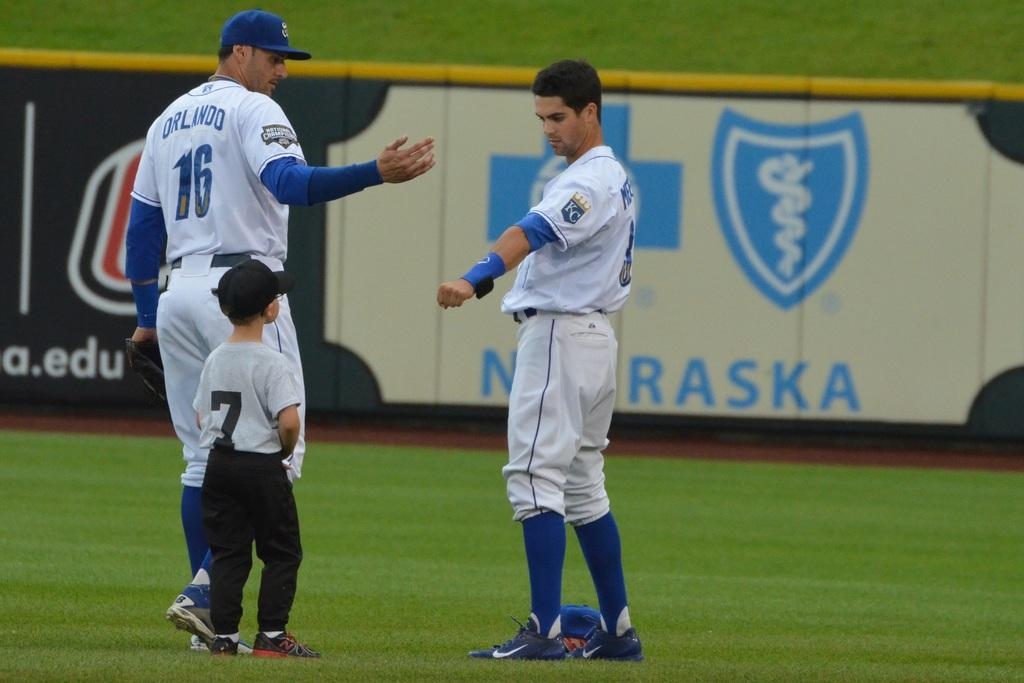<image>
Present a compact description of the photo's key features. Two men wearing Kansas City jerseys stand with a boy wearing a jersey with the number 7. 